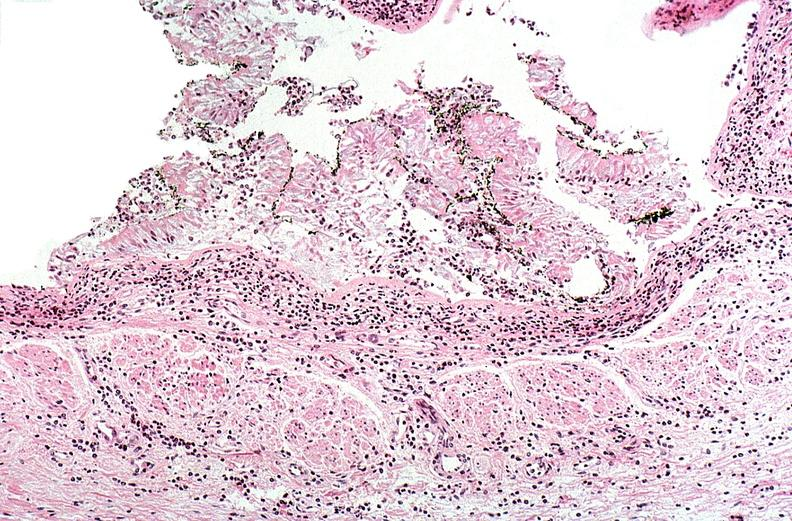do thermal burn?
Answer the question using a single word or phrase. Yes 